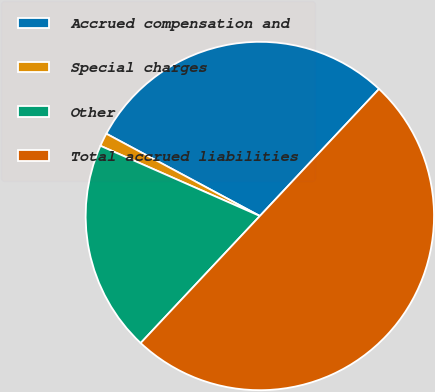Convert chart to OTSL. <chart><loc_0><loc_0><loc_500><loc_500><pie_chart><fcel>Accrued compensation and<fcel>Special charges<fcel>Other<fcel>Total accrued liabilities<nl><fcel>29.16%<fcel>1.23%<fcel>19.61%<fcel>50.0%<nl></chart> 